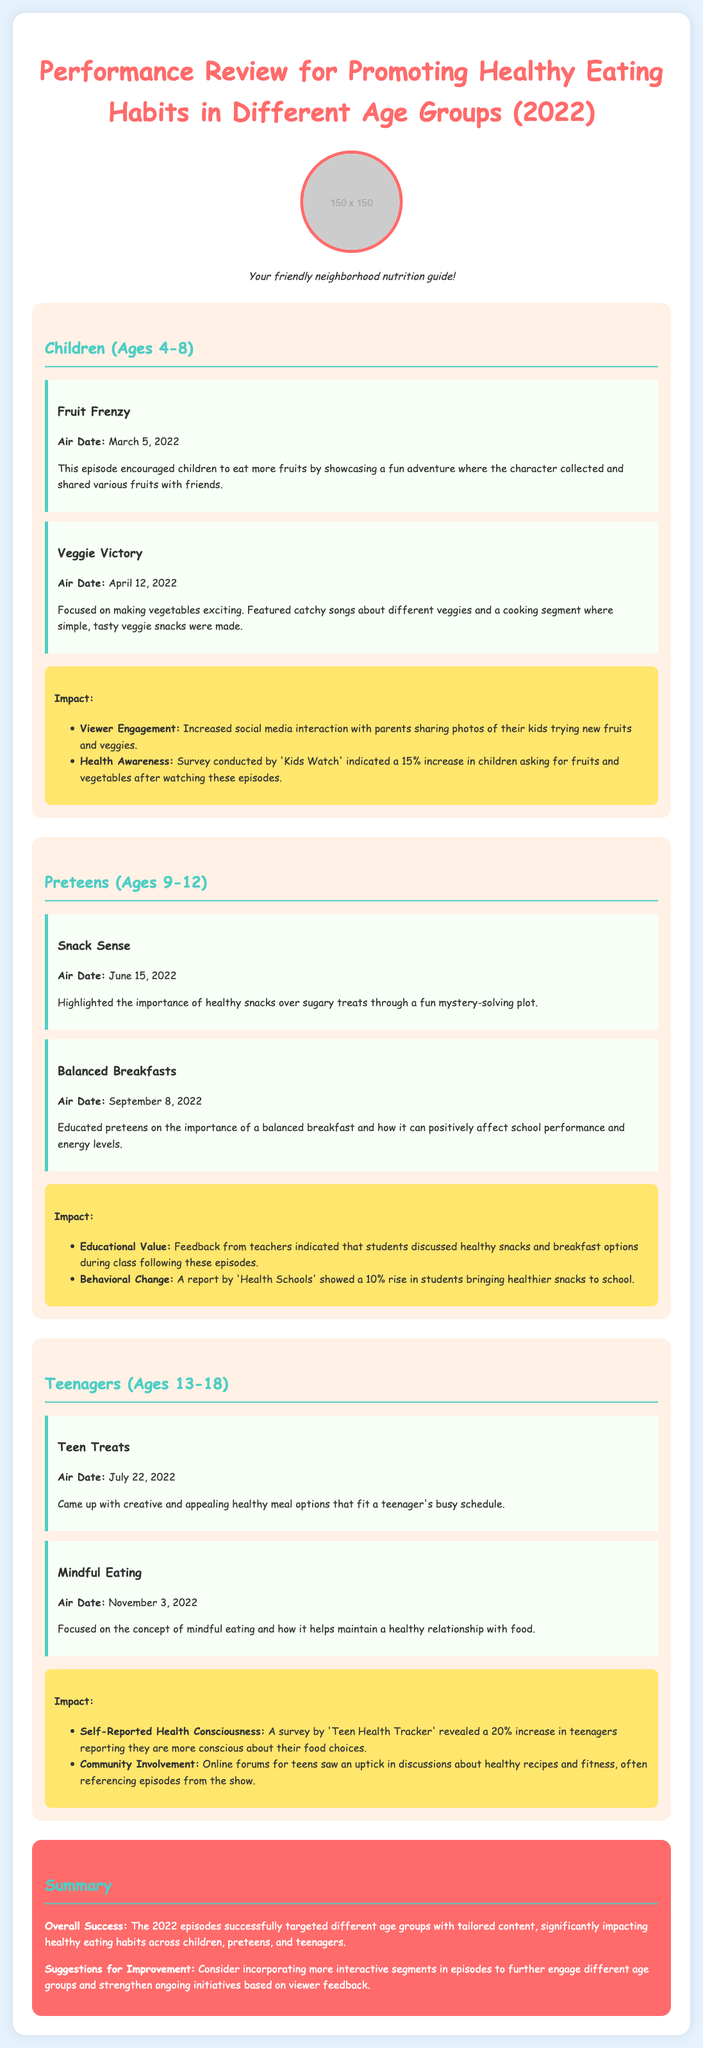What episode aired on March 5, 2022? The episode that aired on March 5, 2022, is titled "Fruit Frenzy."
Answer: Fruit Frenzy What was the main focus of the episode "Veggie Victory"? "Veggie Victory" focused on making vegetables exciting with catchy songs and a cooking segment.
Answer: Making vegetables exciting How much did 'Kids Watch' indicate the increase in children asking for fruits and vegetables? 'Kids Watch' indicated a 15% increase in children asking for fruits and vegetables after watching these episodes.
Answer: 15% What educational value was noted from the "Balanced Breakfasts" episode? Feedback from teachers indicated that students discussed healthy snacks and breakfast options during class.
Answer: Students discussed healthy snacks What percentage of teenagers reported being more conscious about their food choices? A survey by 'Teen Health Tracker' revealed a 20% increase in teenagers reporting they are more conscious about their food choices.
Answer: 20% What is one suggestion for improvement mentioned in the document? One suggestion for improvement is to incorporate more interactive segments in episodes.
Answer: More interactive segments Which age group was the episode "Snack Sense" targeted towards? "Snack Sense" was targeted towards preteens, ages 9-12.
Answer: Preteens What was the air date of the episode "Mindful Eating"? The air date of "Mindful Eating" was November 3, 2022.
Answer: November 3, 2022 What type of feedback was received for the “Teen Treats” episode? Online forums for teens saw an uptick in discussions about healthy recipes and fitness related to "Teen Treats."
Answer: Uptick in discussions 